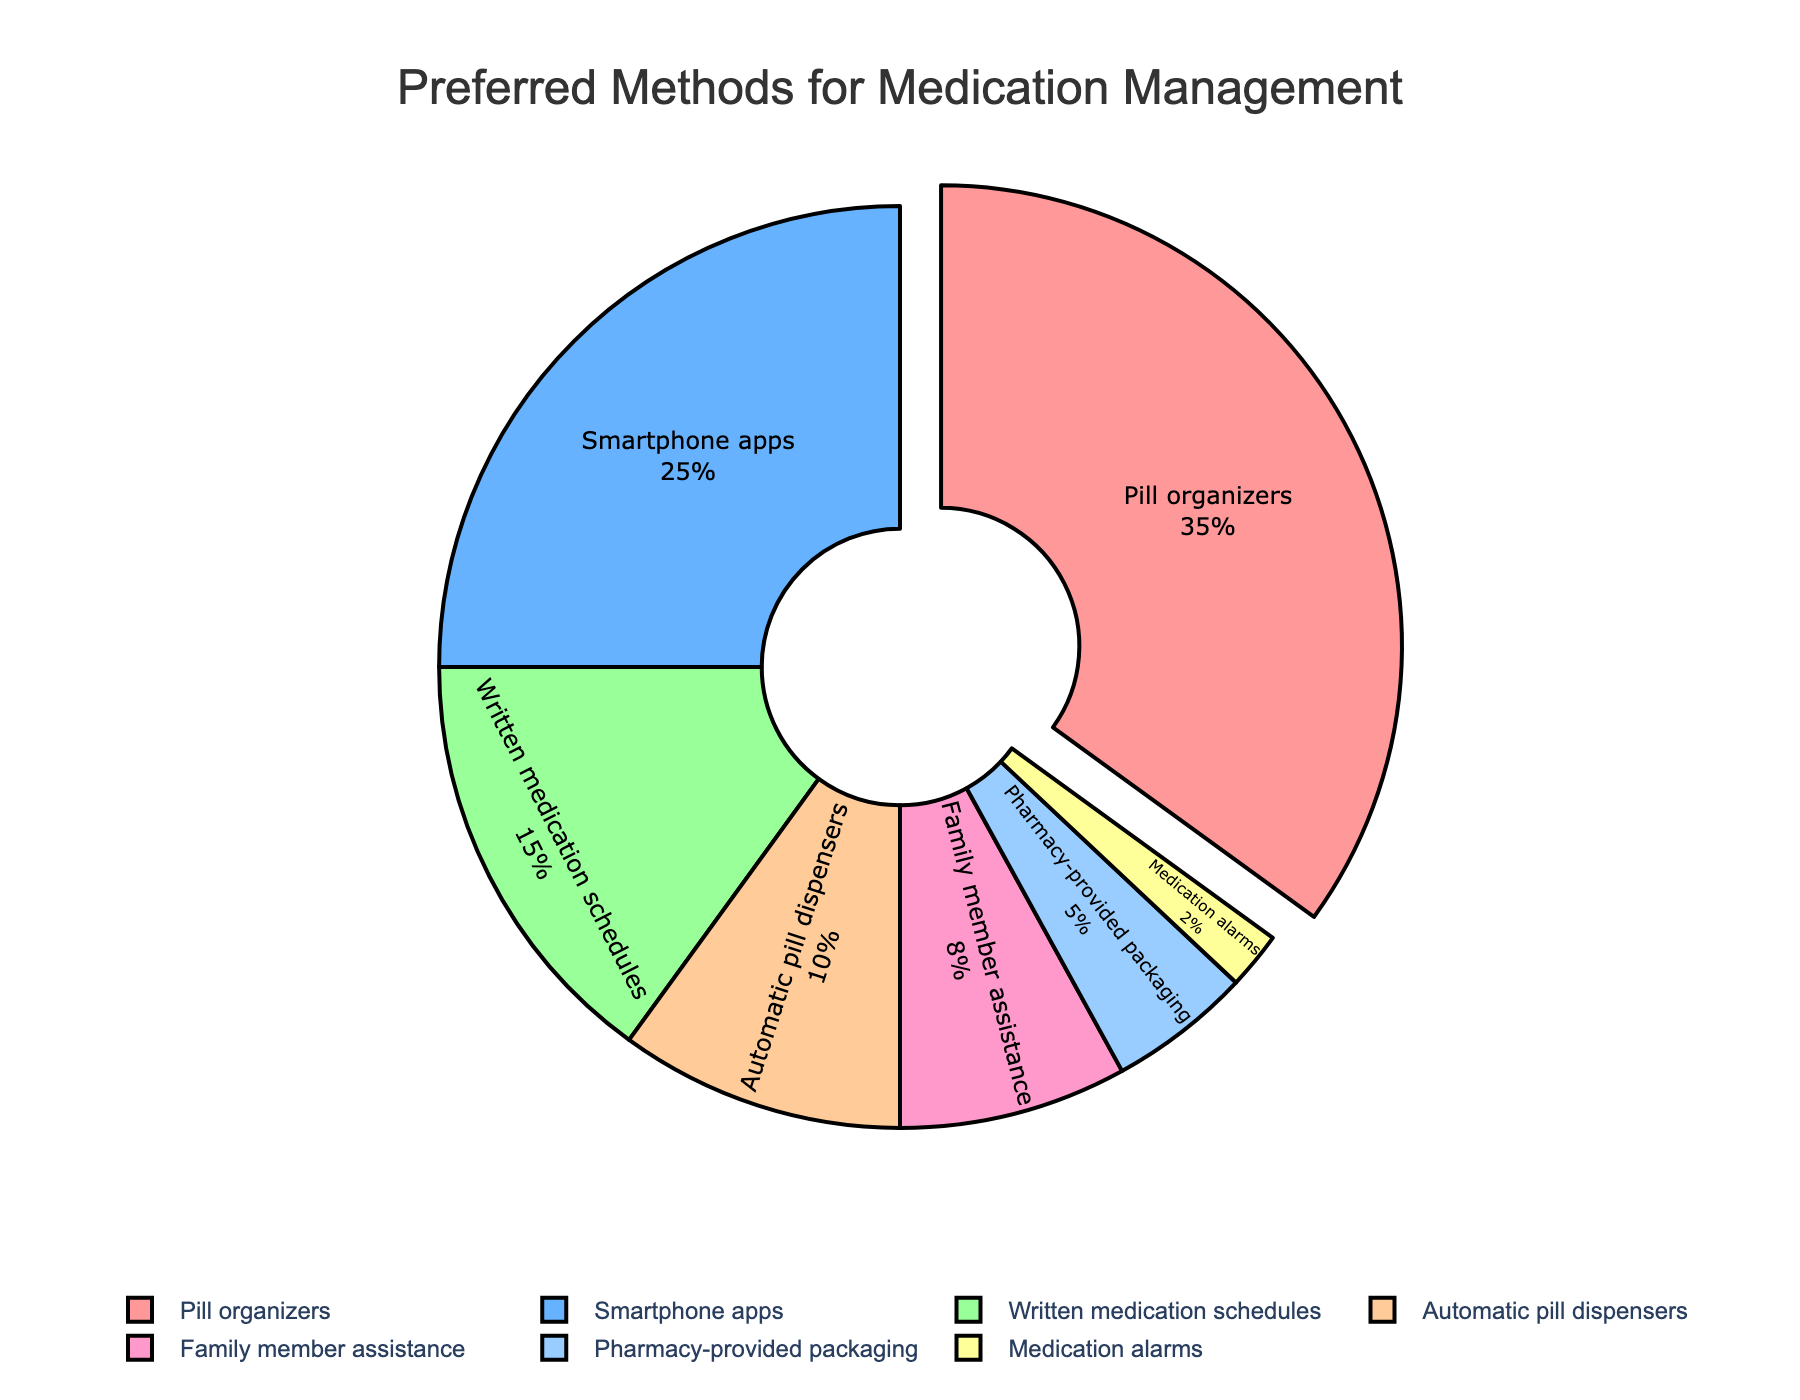What is the most preferred method for medication management? The figure highlights the most preferred method by pulling it slightly outward from the pie. Observing the pie chart, the method "Pill organizers" is pulled out and has the highest percentage.
Answer: Pill organizers What is the combined percentage of those using smartphone apps and automatic pill dispensers? Add the percentage values of "Smartphone apps" (25) and "Automatic pill dispensers" (10). The sum is 25 + 10.
Answer: 35 Which method is least preferred among the patients? The pie chart shows the smallest section representing the least percentage of 2%, labeled as "Medication alarms."
Answer: Medication alarms How many methods have a preference percentage higher than 10%? Observing the chart, count the segments with values: "Pill organizers" (35%), "Smartphone apps" (25%), "Written medication schedules" (15%), and "Automatic pill dispensers" (10%). This results in 4 methods.
Answer: 4 What percentage difference is there between the most and least preferred methods? Subtract the percentage of "Medication alarms" (2%) from "Pill organizers" (35%). The calculation is 35 - 2.
Answer: 33 Is the preference for family member assistance higher or lower than that for written medication schedules? Compare the percentage values: "Family member assistance" (8%) is lower than "Written medication schedules" (15%).
Answer: Lower If the total number of participants is 200, how many use pharmacy-provided packaging? Calculate 5% of 200. The calculation is 200 * 0.05.
Answer: 10 Which methods are represented by colors in shades of blue? Identify and describe the colors linked to each segment. "Smartphone apps" and "Pharmacy-provided packaging" use shades of blue.
Answer: Smartphone apps, Pharmacy-provided packaging What is the total percentage of participants using either pill organizers or family member assistance? Add the percentages of "Pill organizers" (35) and "Family member assistance" (8). The sum is 35 + 8.
Answer: 43 How many methods have a preference percentage that is less than 10%? Count the segments with values: "Family member assistance" (8%), "Pharmacy-provided packaging" (5%), and "Medication alarms" (2%). This results in 3 methods.
Answer: 3 